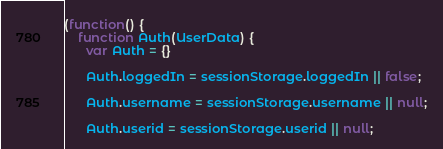Convert code to text. <code><loc_0><loc_0><loc_500><loc_500><_JavaScript_>(function() {
    function Auth(UserData) {
      var Auth = {}

      Auth.loggedIn = sessionStorage.loggedIn || false;

      Auth.username = sessionStorage.username || null;

      Auth.userid = sessionStorage.userid || null;
</code> 